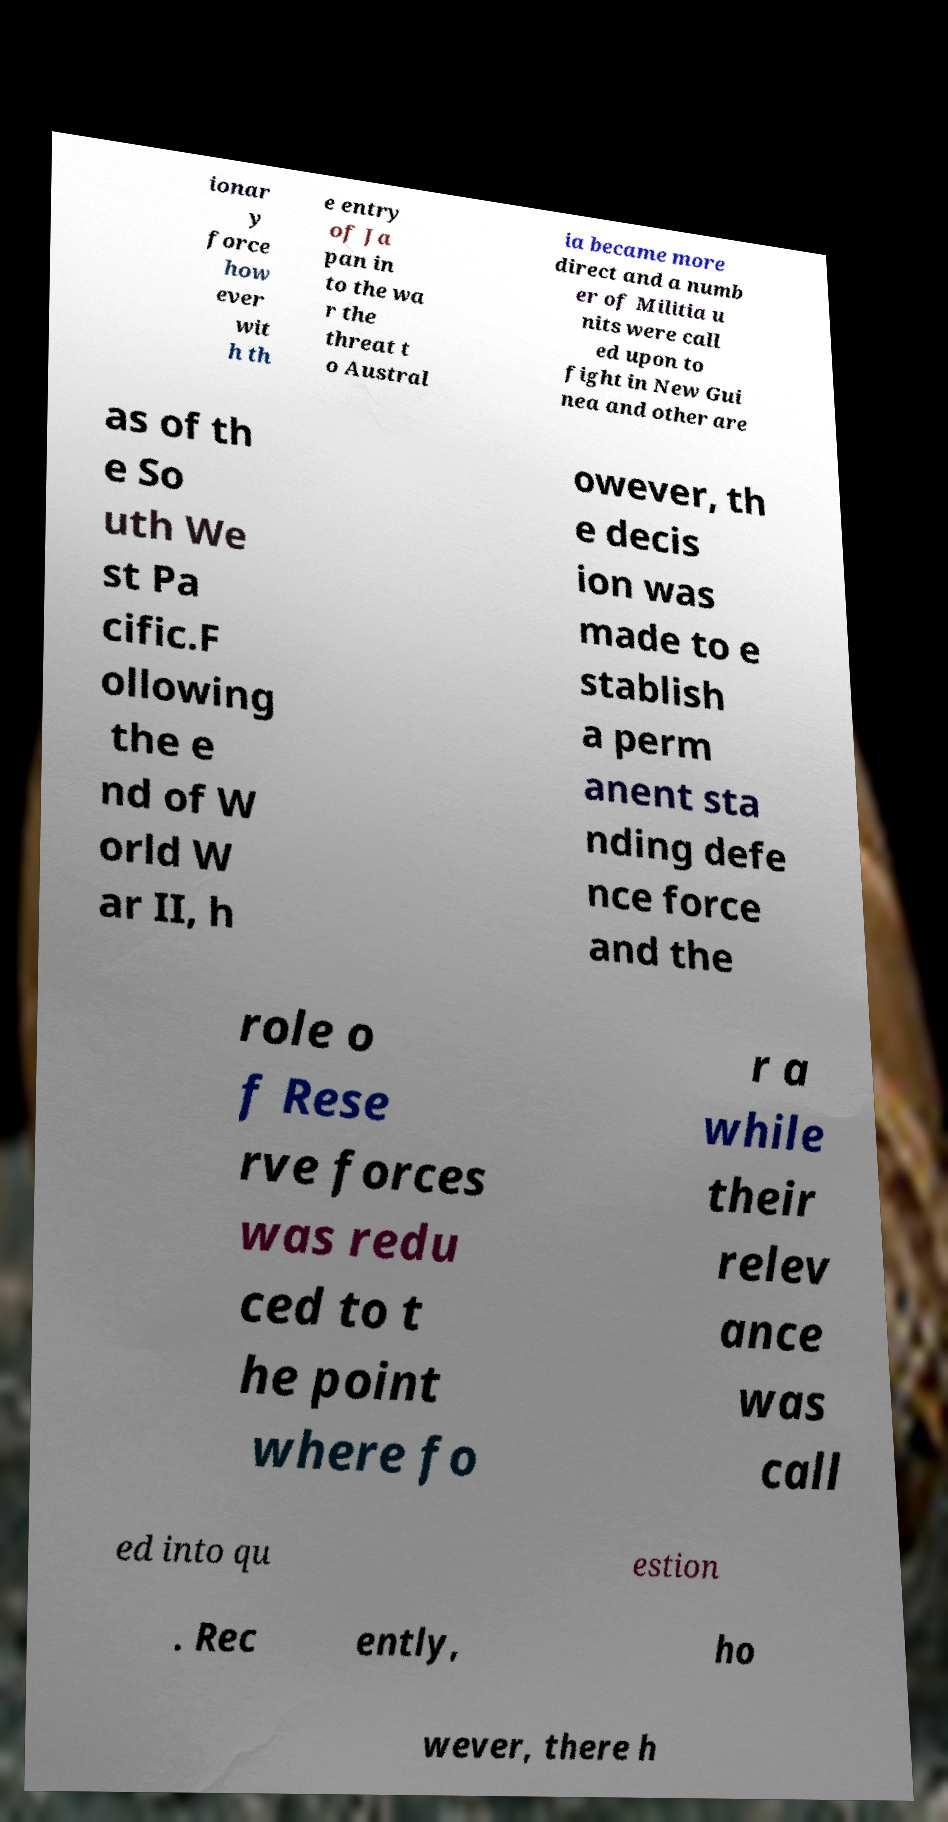Can you read and provide the text displayed in the image?This photo seems to have some interesting text. Can you extract and type it out for me? ionar y force how ever wit h th e entry of Ja pan in to the wa r the threat t o Austral ia became more direct and a numb er of Militia u nits were call ed upon to fight in New Gui nea and other are as of th e So uth We st Pa cific.F ollowing the e nd of W orld W ar II, h owever, th e decis ion was made to e stablish a perm anent sta nding defe nce force and the role o f Rese rve forces was redu ced to t he point where fo r a while their relev ance was call ed into qu estion . Rec ently, ho wever, there h 